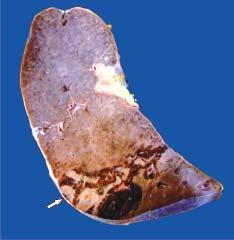s a wedge-shaped shrunken area of pale colour seen with base resting under the capsule, while the margin is congested?
Answer the question using a single word or phrase. Yes 